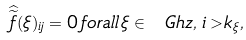Convert formula to latex. <formula><loc_0><loc_0><loc_500><loc_500>\widehat { \widetilde { f } } ( \xi ) _ { i j } = 0 \, f o r a l l \, \xi \in \ G h z , \, i > k _ { \xi } ,</formula> 